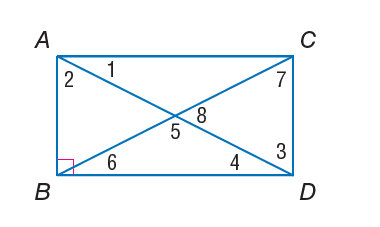Answer the mathemtical geometry problem and directly provide the correct option letter.
Question: Quadrilateral A B C D is a rectangle. m \angle 2 = 40. Find m \angle 6.
Choices: A: 40 B: 50 C: 80 D: 100 B 